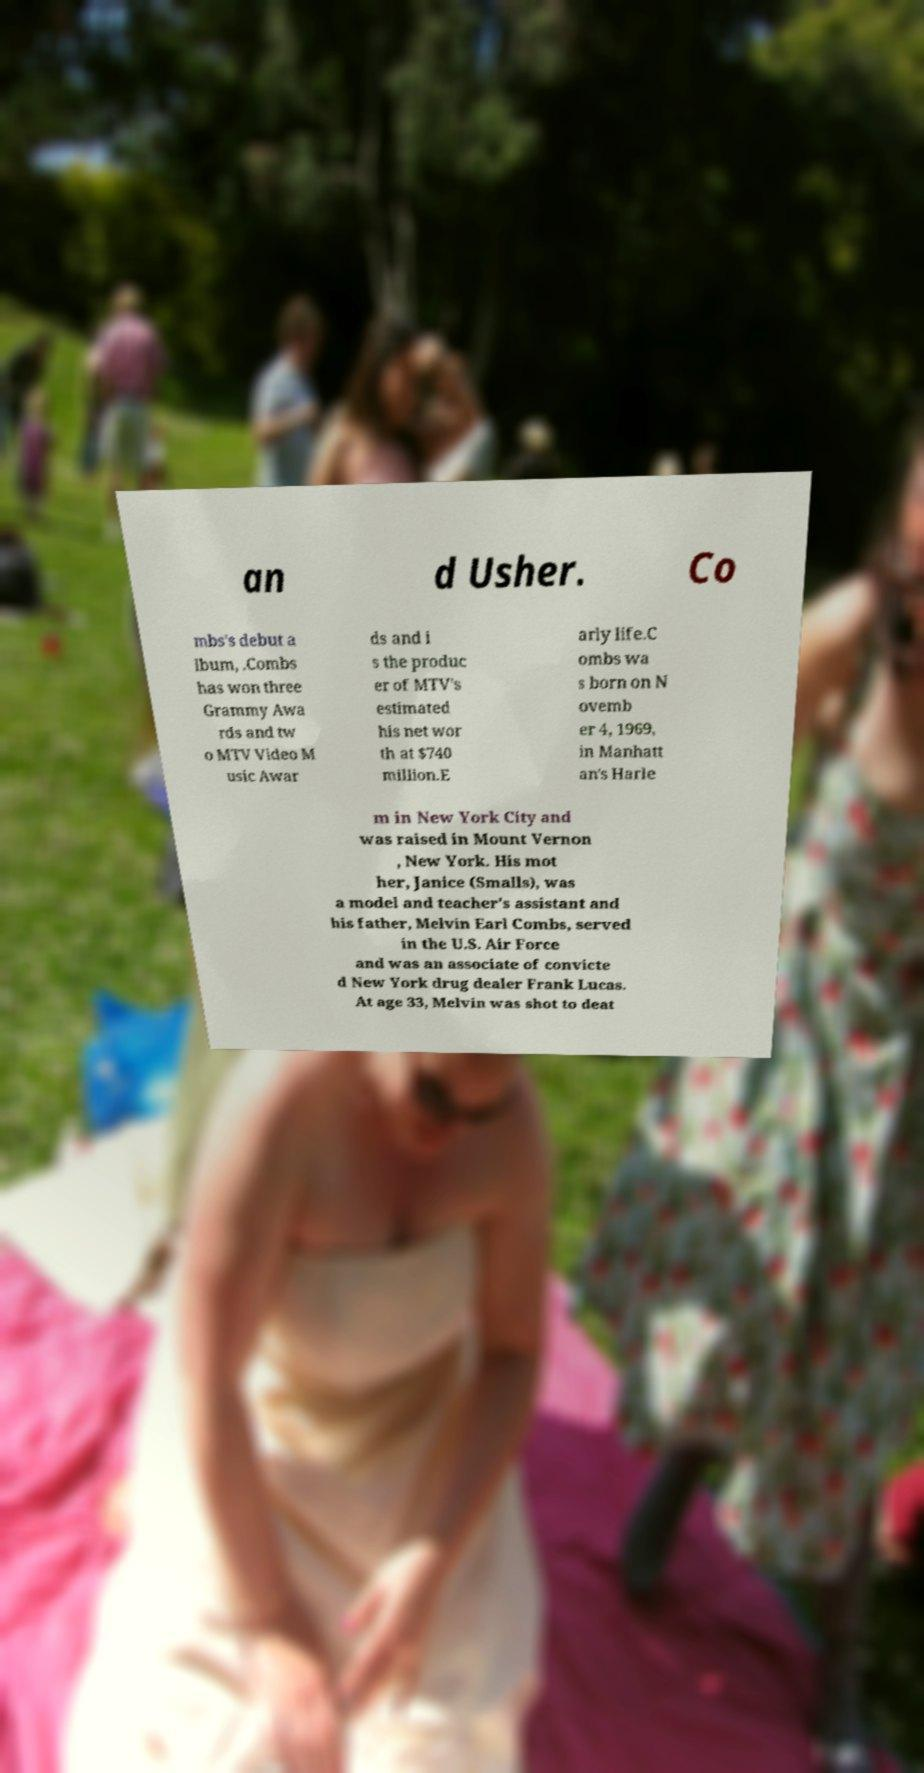Please identify and transcribe the text found in this image. an d Usher. Co mbs's debut a lbum, .Combs has won three Grammy Awa rds and tw o MTV Video M usic Awar ds and i s the produc er of MTV's estimated his net wor th at $740 million.E arly life.C ombs wa s born on N ovemb er 4, 1969, in Manhatt an's Harle m in New York City and was raised in Mount Vernon , New York. His mot her, Janice (Smalls), was a model and teacher's assistant and his father, Melvin Earl Combs, served in the U.S. Air Force and was an associate of convicte d New York drug dealer Frank Lucas. At age 33, Melvin was shot to deat 